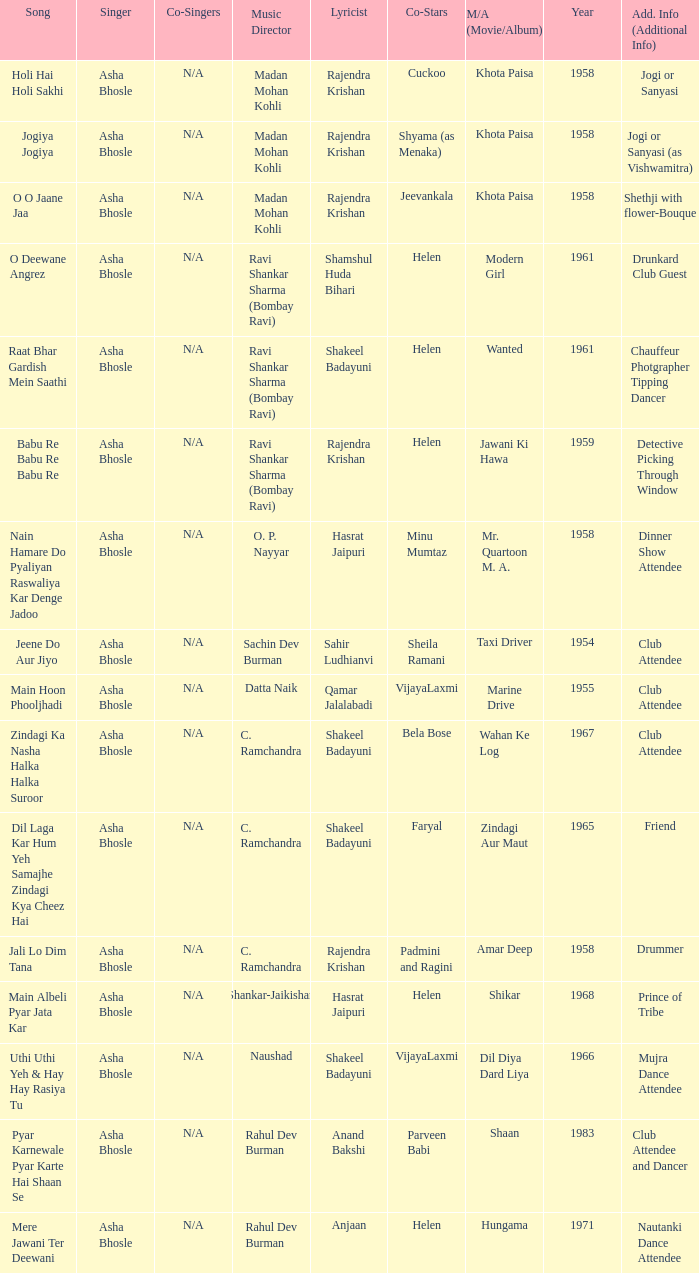What movie did Bela Bose co-star in? Wahan Ke Log. 